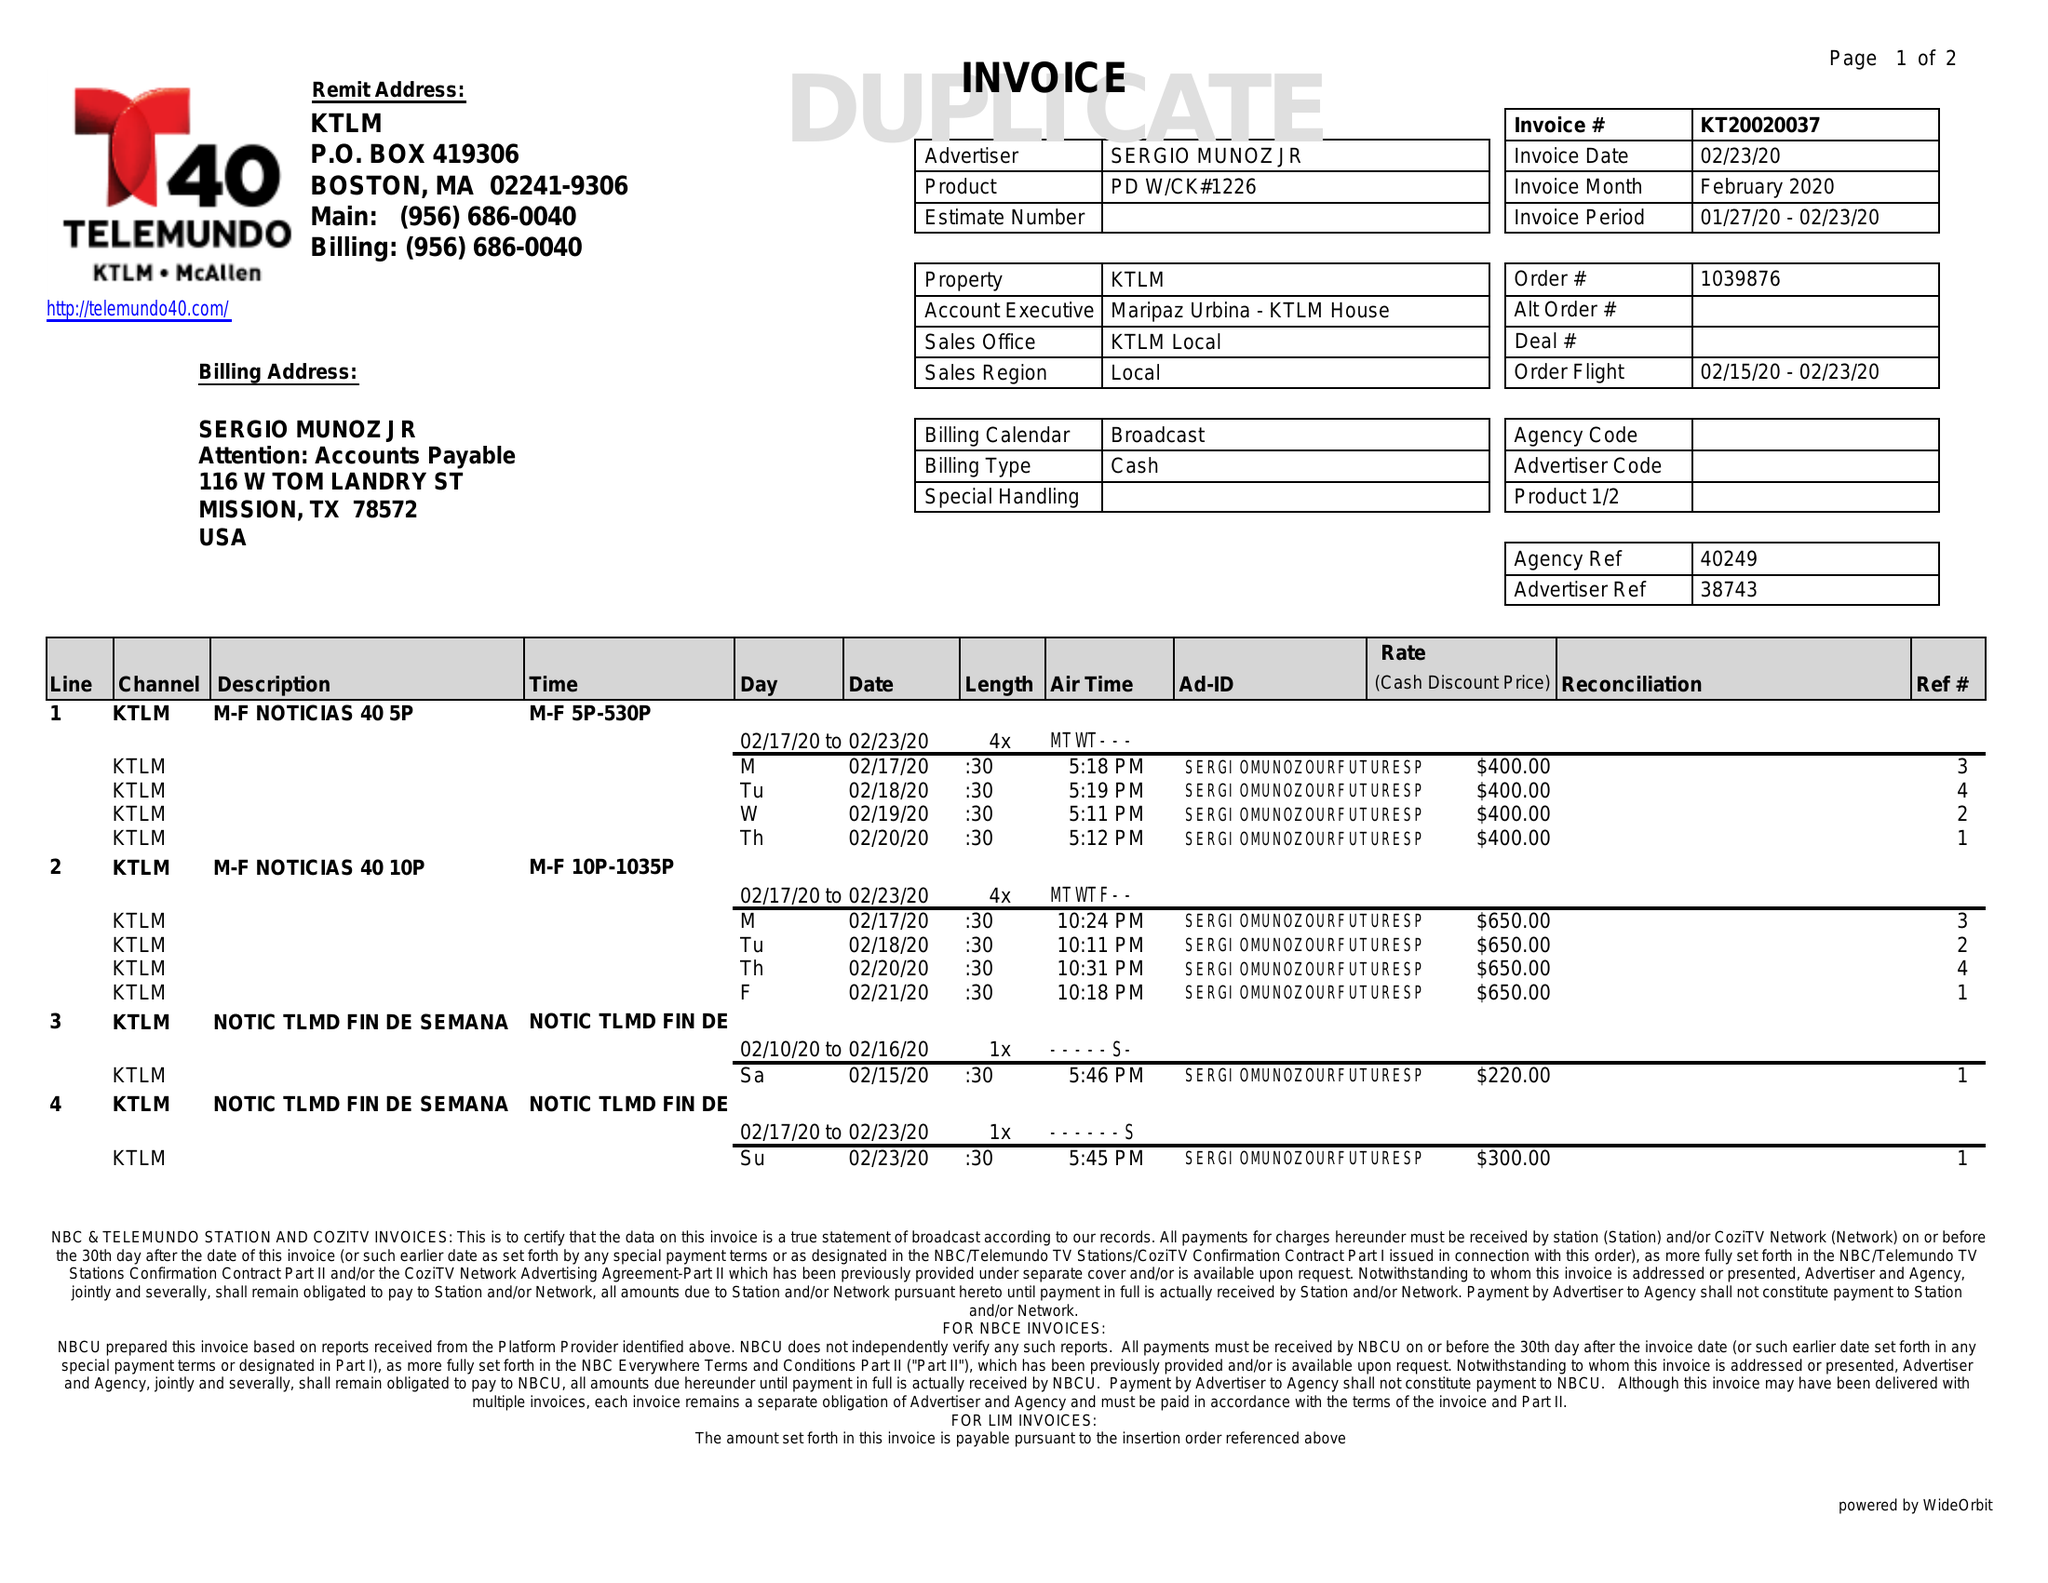What is the value for the advertiser?
Answer the question using a single word or phrase. SERGIO MUNOZ JR 